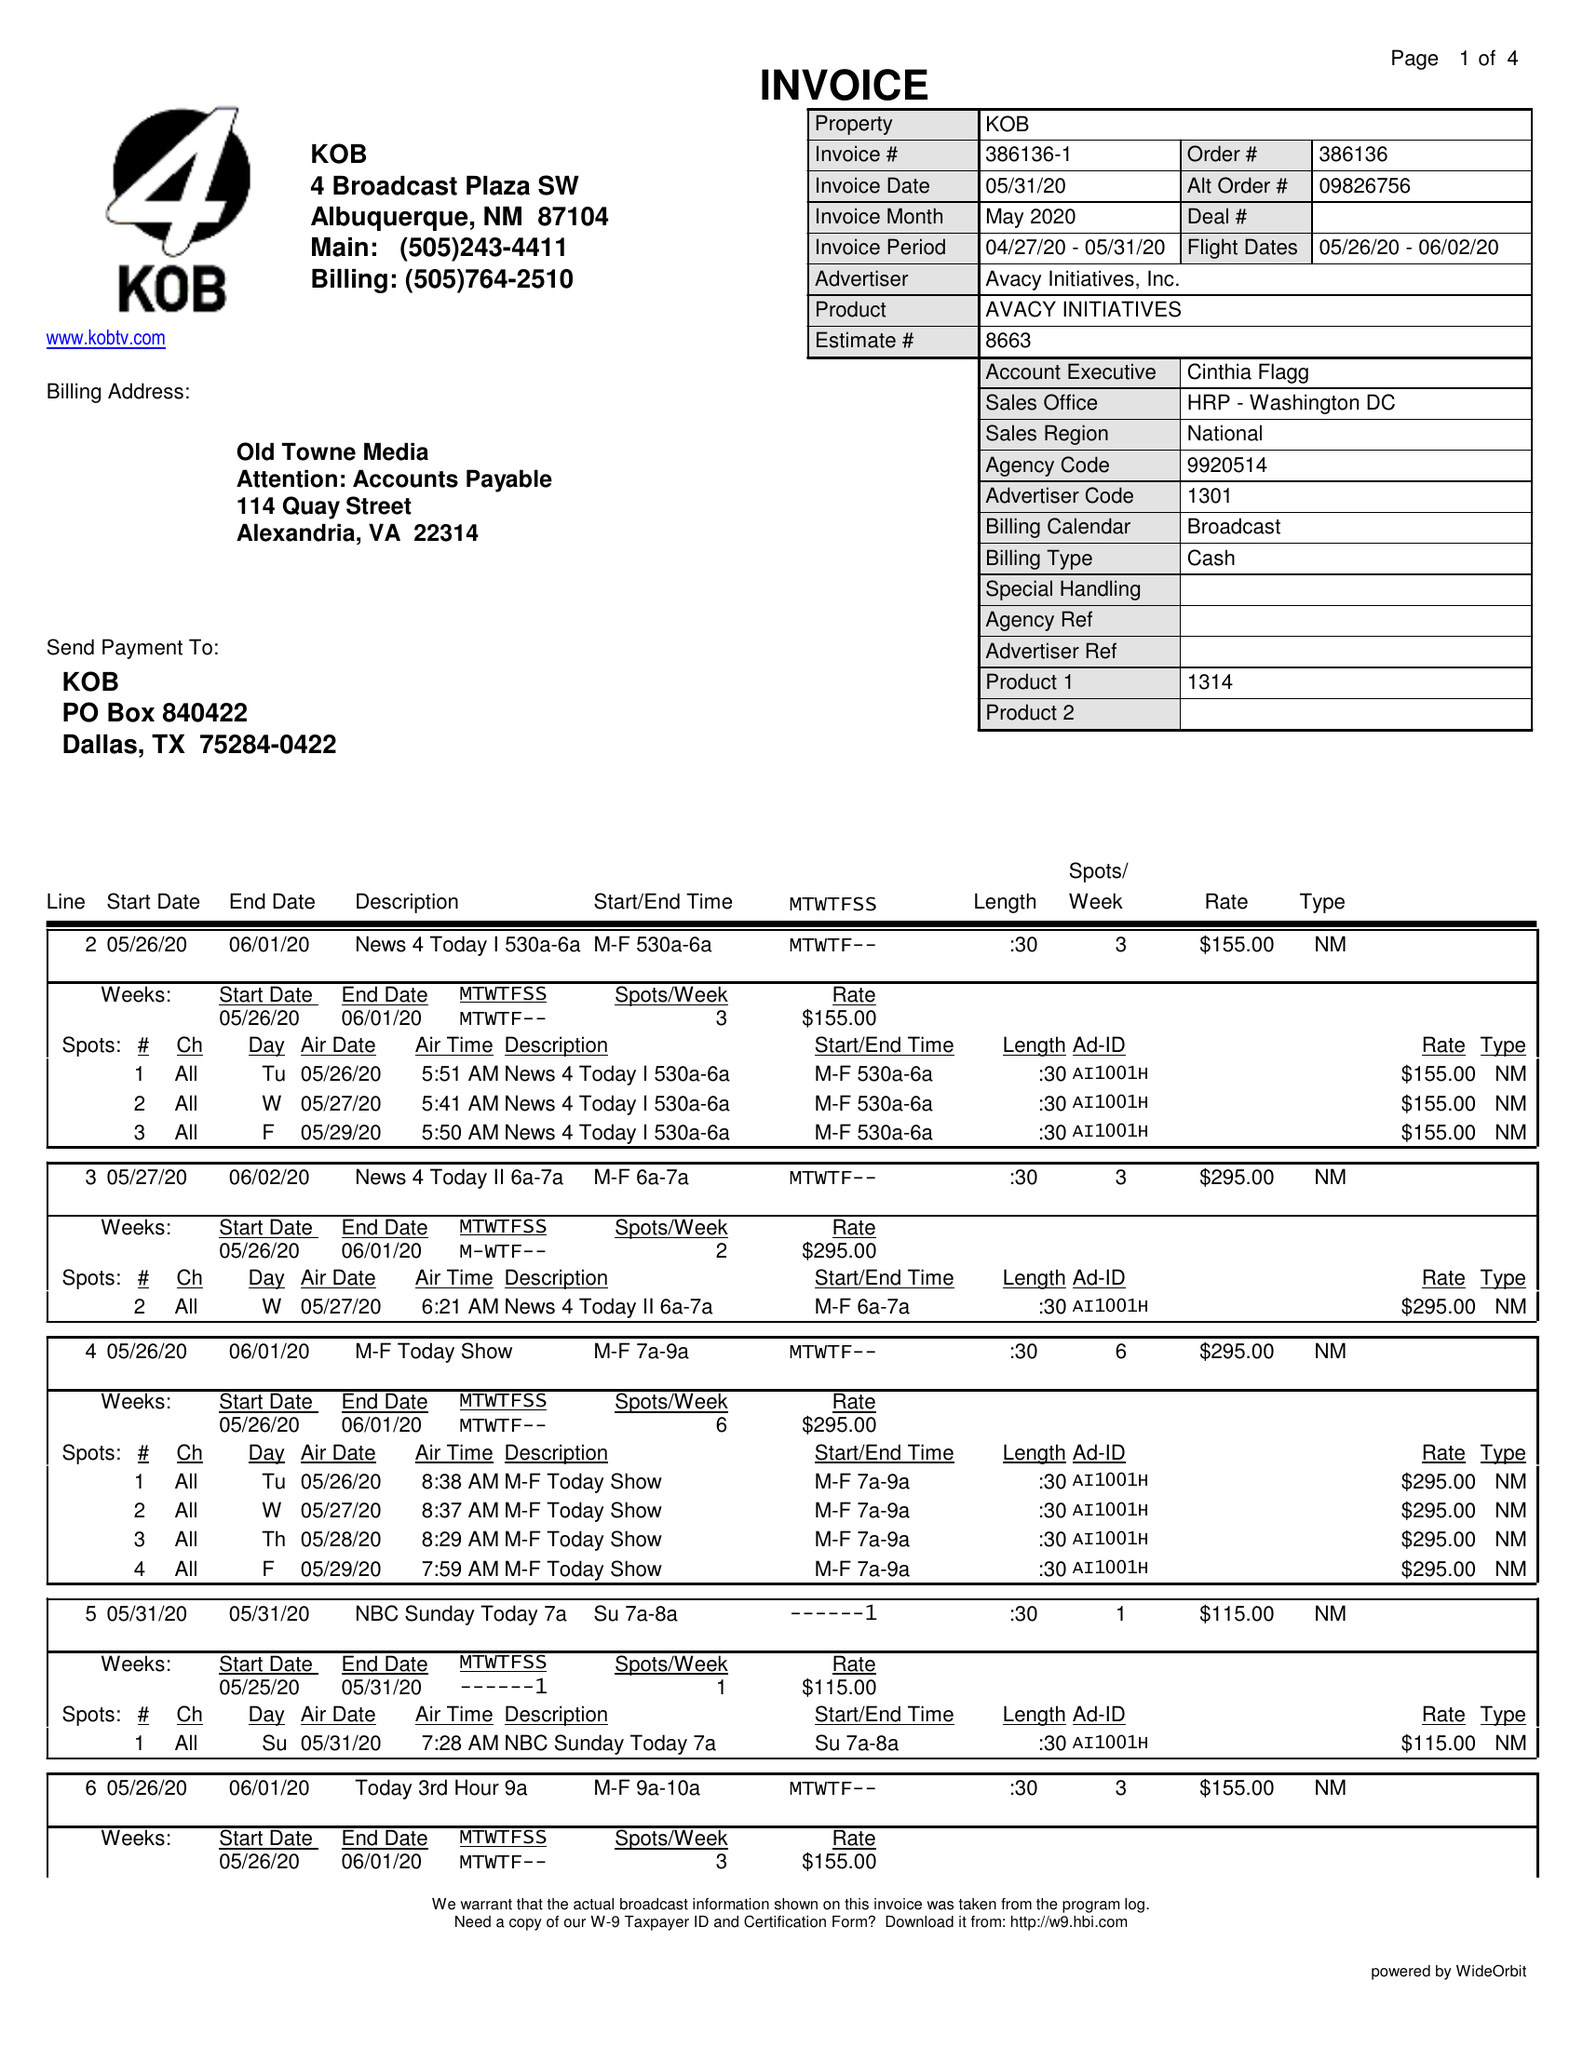What is the value for the gross_amount?
Answer the question using a single word or phrase. 9320.00 